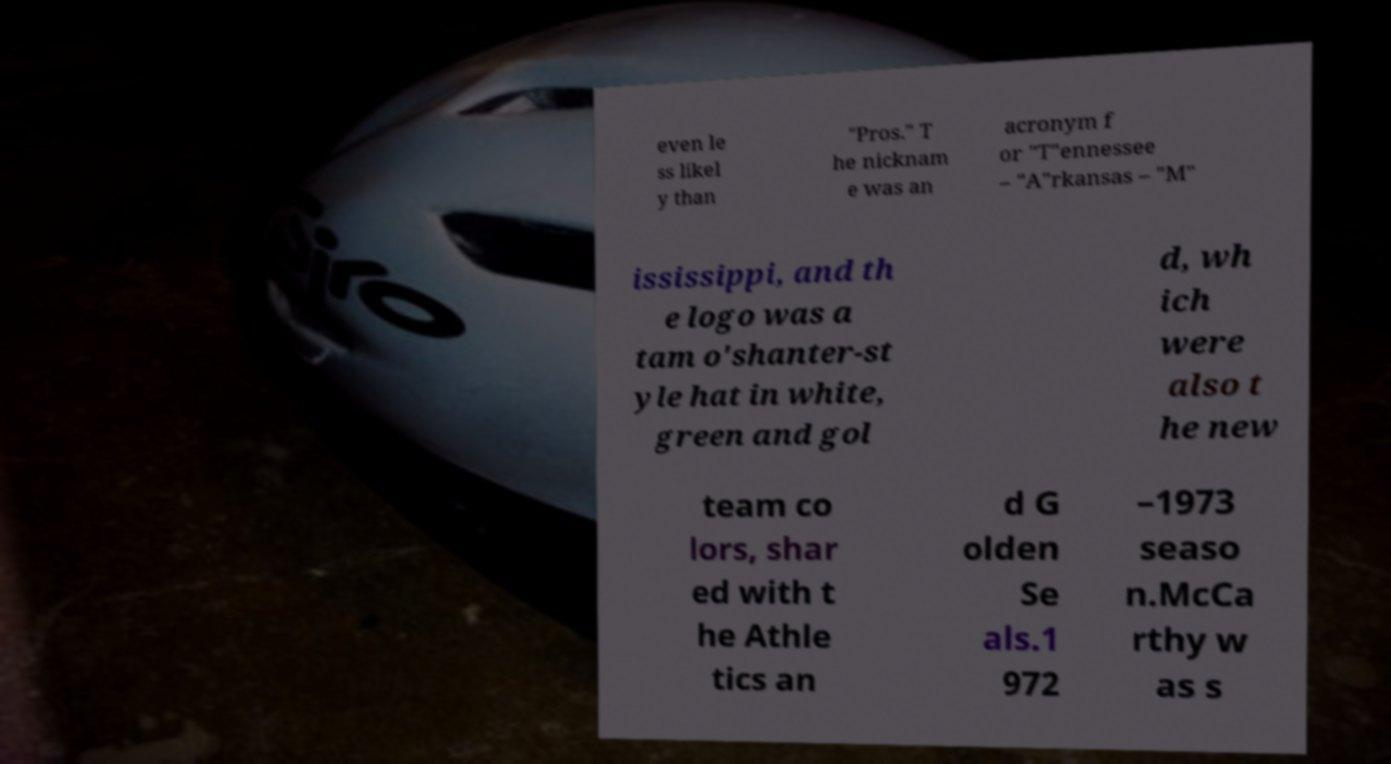Can you read and provide the text displayed in the image?This photo seems to have some interesting text. Can you extract and type it out for me? even le ss likel y than "Pros." T he nicknam e was an acronym f or "T"ennessee – "A"rkansas – "M" ississippi, and th e logo was a tam o'shanter-st yle hat in white, green and gol d, wh ich were also t he new team co lors, shar ed with t he Athle tics an d G olden Se als.1 972 –1973 seaso n.McCa rthy w as s 